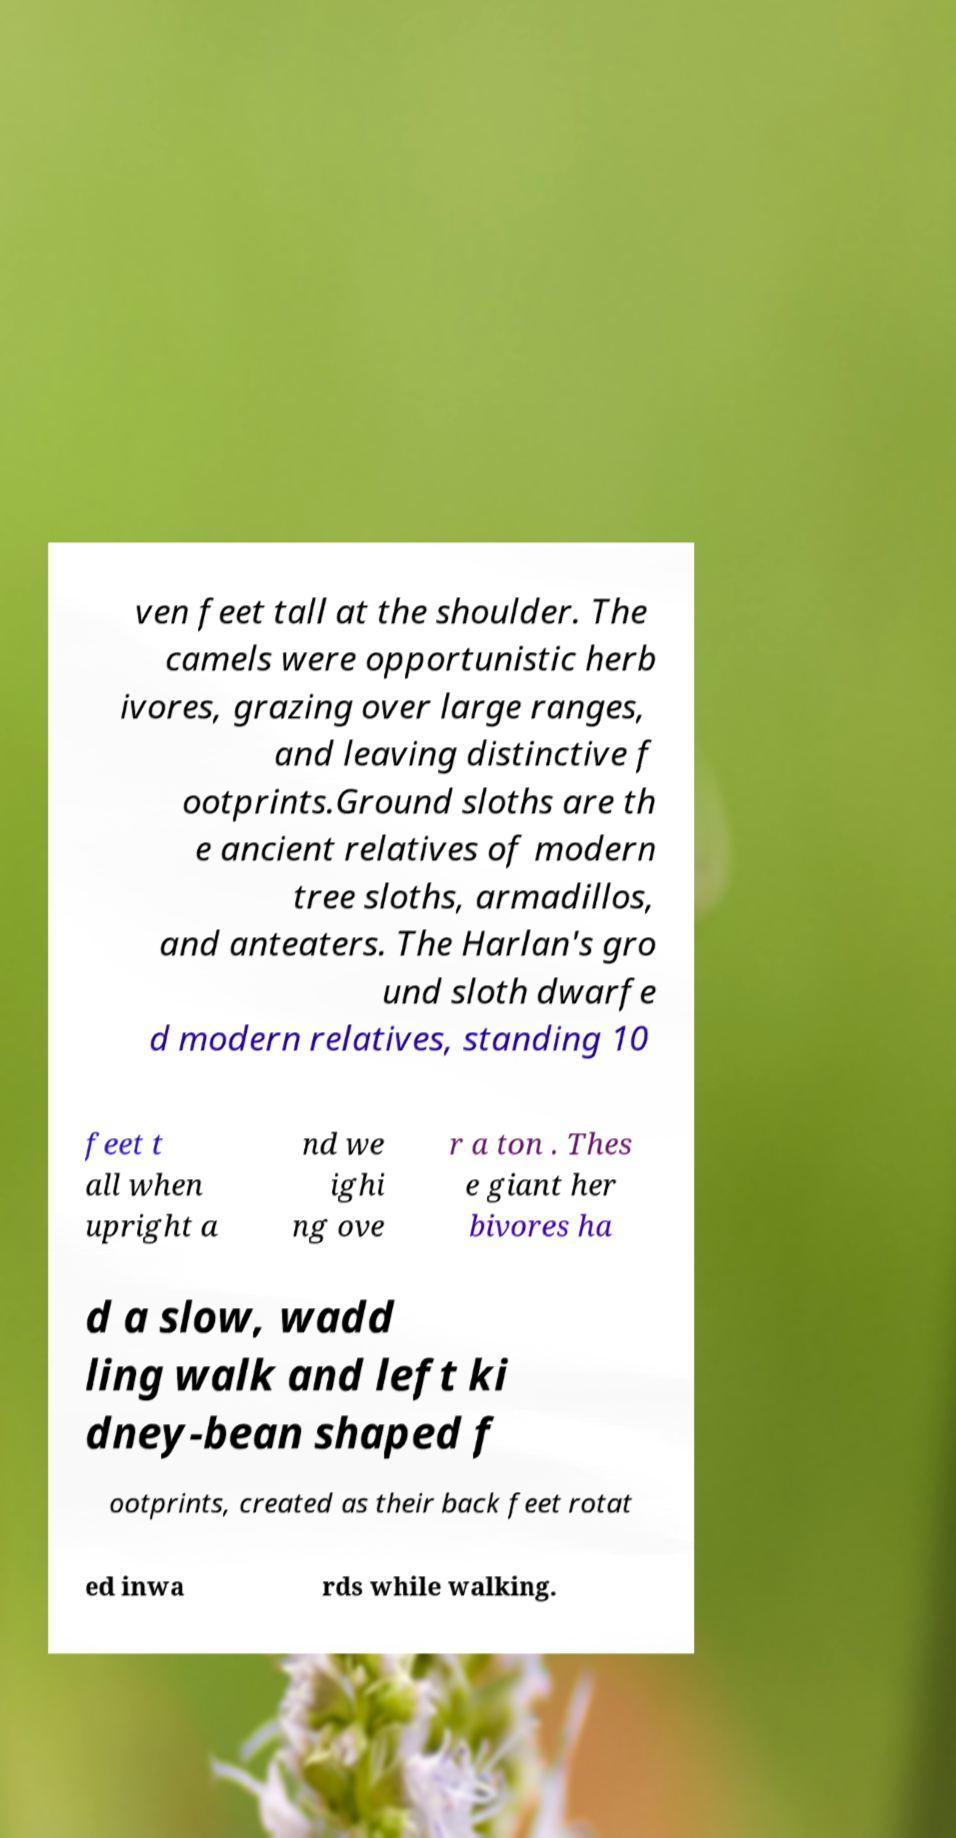For documentation purposes, I need the text within this image transcribed. Could you provide that? ven feet tall at the shoulder. The camels were opportunistic herb ivores, grazing over large ranges, and leaving distinctive f ootprints.Ground sloths are th e ancient relatives of modern tree sloths, armadillos, and anteaters. The Harlan's gro und sloth dwarfe d modern relatives, standing 10 feet t all when upright a nd we ighi ng ove r a ton . Thes e giant her bivores ha d a slow, wadd ling walk and left ki dney-bean shaped f ootprints, created as their back feet rotat ed inwa rds while walking. 